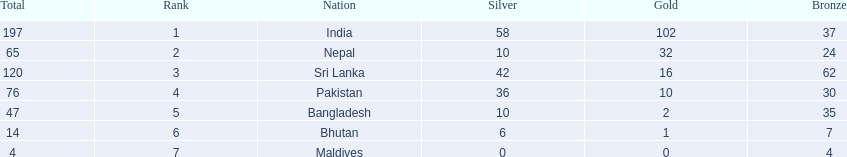What are the totals of medals one in each country? 197, 65, 120, 76, 47, 14, 4. Could you parse the entire table? {'header': ['Total', 'Rank', 'Nation', 'Silver', 'Gold', 'Bronze'], 'rows': [['197', '1', 'India', '58', '102', '37'], ['65', '2', 'Nepal', '10', '32', '24'], ['120', '3', 'Sri Lanka', '42', '16', '62'], ['76', '4', 'Pakistan', '36', '10', '30'], ['47', '5', 'Bangladesh', '10', '2', '35'], ['14', '6', 'Bhutan', '6', '1', '7'], ['4', '7', 'Maldives', '0', '0', '4']]} Which of these totals are less than 10? 4. Who won this number of medals? Maldives. 